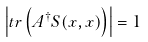<formula> <loc_0><loc_0><loc_500><loc_500>\left | t r \left ( A ^ { \dagger } S ( x , x ) \right ) \right | = 1</formula> 